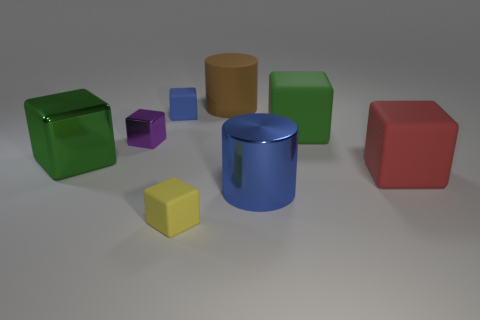What number of matte cubes are the same color as the metallic cylinder?
Your answer should be very brief. 1. Is the size of the blue thing that is in front of the red matte object the same as the yellow block?
Keep it short and to the point. No. The large cube that is both to the right of the blue cube and to the left of the red cube is what color?
Give a very brief answer. Green. What number of things are either gray cylinders or metal things behind the red rubber object?
Your answer should be very brief. 2. The big green thing in front of the large green cube that is to the right of the green thing that is to the left of the brown rubber object is made of what material?
Keep it short and to the point. Metal. There is a small rubber thing behind the large metal cube; is its color the same as the big metal cylinder?
Keep it short and to the point. Yes. What number of cyan objects are either matte objects or rubber blocks?
Give a very brief answer. 0. What number of other things are there of the same shape as the big blue object?
Offer a very short reply. 1. Is the material of the big red thing the same as the tiny blue cube?
Give a very brief answer. Yes. There is a big thing that is to the left of the green matte object and in front of the large metal block; what material is it made of?
Your answer should be compact. Metal. 